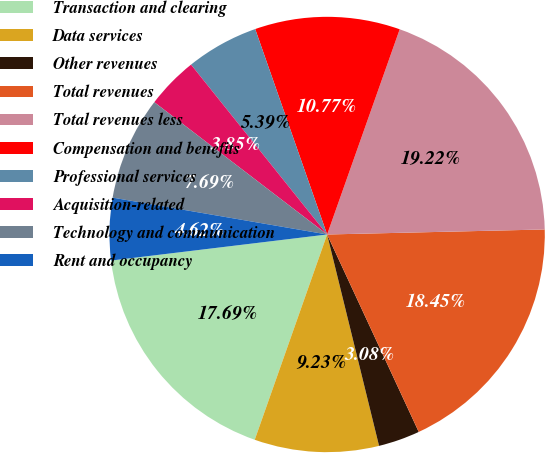Convert chart to OTSL. <chart><loc_0><loc_0><loc_500><loc_500><pie_chart><fcel>Transaction and clearing<fcel>Data services<fcel>Other revenues<fcel>Total revenues<fcel>Total revenues less<fcel>Compensation and benefits<fcel>Professional services<fcel>Acquisition-related<fcel>Technology and communication<fcel>Rent and occupancy<nl><fcel>17.69%<fcel>9.23%<fcel>3.08%<fcel>18.45%<fcel>19.22%<fcel>10.77%<fcel>5.39%<fcel>3.85%<fcel>7.69%<fcel>4.62%<nl></chart> 